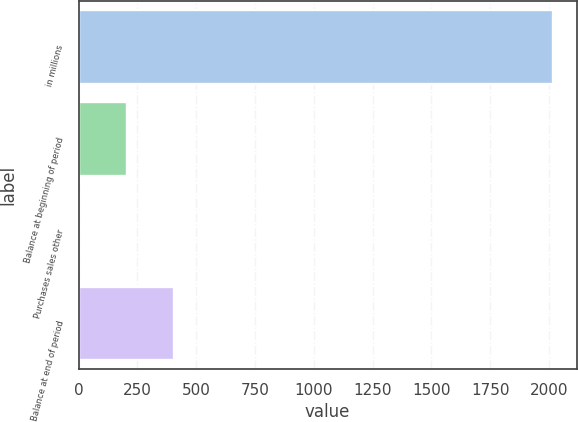Convert chart to OTSL. <chart><loc_0><loc_0><loc_500><loc_500><bar_chart><fcel>in millions<fcel>Balance at beginning of period<fcel>Purchases sales other<fcel>Balance at end of period<nl><fcel>2016<fcel>204.3<fcel>3<fcel>405.6<nl></chart> 